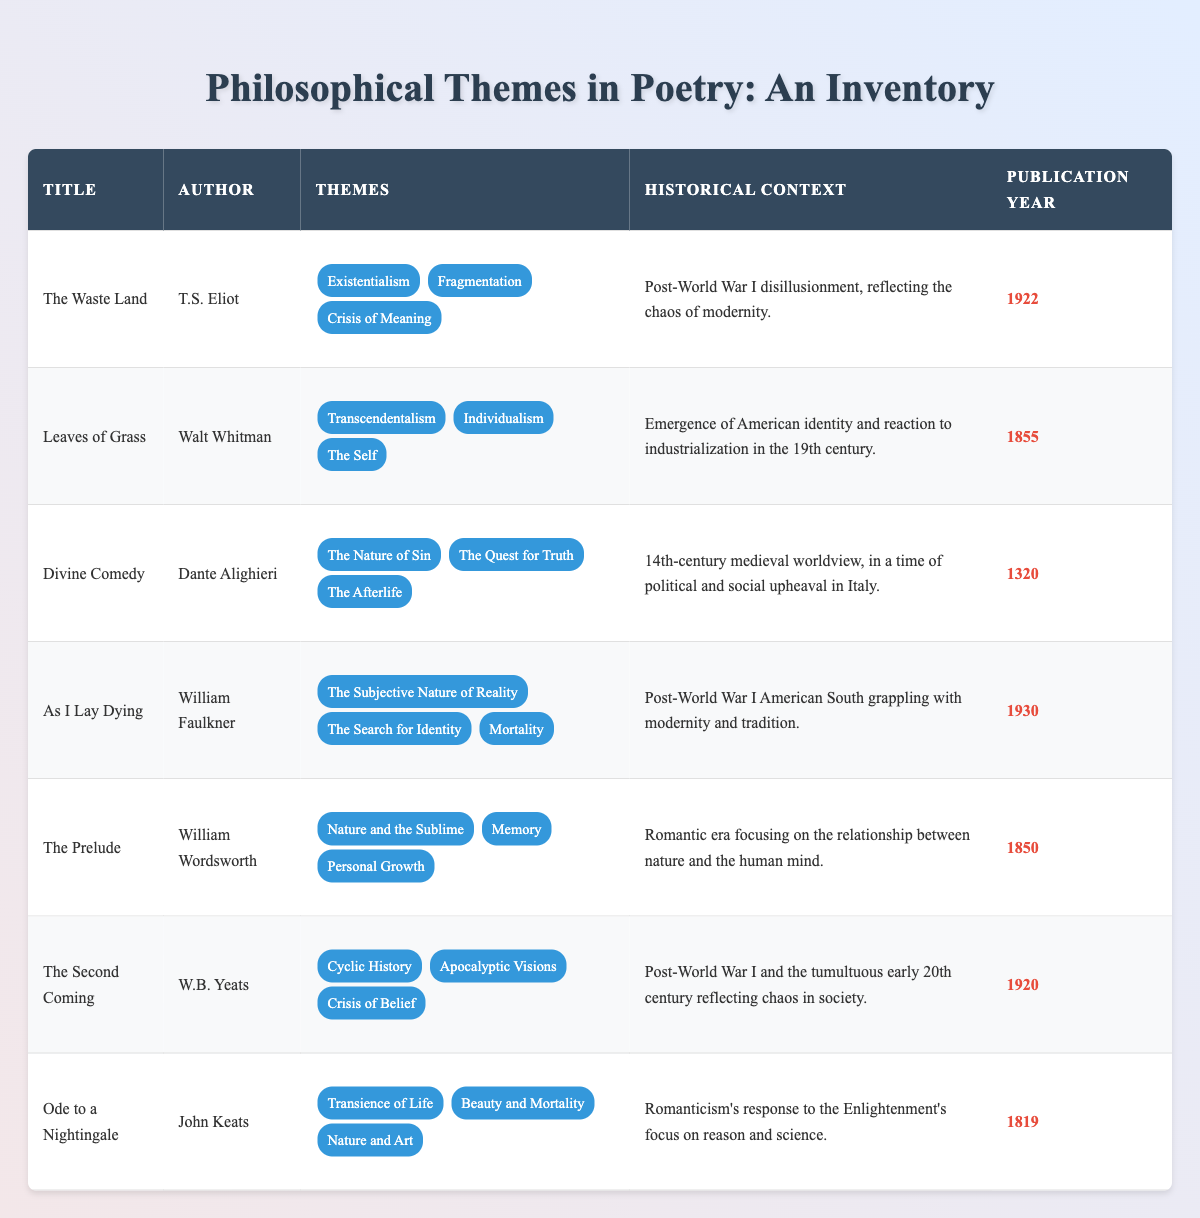What is the publication year of "The Waste Land"? The publication year for "The Waste Land" is listed in the table, where the corresponding row shows the year next to the title. Therefore, by checking the relevant column, we find that it was published in 1922.
Answer: 1922 Which author wrote "Leaves of Grass"? The title "Leaves of Grass" corresponds to the author listed in the same row of the table. Upon reviewing the author column for that title, we see it is Walt Whitman.
Answer: Walt Whitman How many themes are associated with "Ode to a Nightingale"? The number of themes for "Ode to a Nightingale" can be determined by counting the list of themes in the corresponding row of the table. There are three themes listed for this poem: Transience of Life, Beauty and Mortality, and Nature and Art.
Answer: 3 Which poem's themes include "Existentialism"? To answer this question, we look for the theme "Existentialism" in the themes column of the table. By scanning through the themes, we find that it is listed in the row for "The Waste Land."
Answer: The Waste Land Was "The Prelude" published before 1900? To determine this, we need to check the publication year for "The Prelude" in the table. The publication year is 1850, which is indeed before 1900.
Answer: Yes Which themes are present in both "The Second Coming" and "The Waste Land"? We review the themes for each of these two poems in their respective rows. "The Second Coming" includes Cyclic History, Apocalyptic Visions, and Crisis of Belief, while "The Waste Land" contains Existentialism, Fragmentation, and Crisis of Meaning. The only overlapping theme here is "Crisis of Meaning," which suggests a connection between the crises depicted in the two works.
Answer: Crisis of Meaning What is the historical context for "Divine Comedy"? The historical context can be found in the specific row corresponding to "Divine Comedy" in the table. It is noted as reflective of the 14th-century medieval worldview during a time of political and social upheaval in Italy. This detailed context helps us understand the environment in which Dante was writing.
Answer: 14th-century medieval worldview, in a time of political and social upheaval in Italy Which poem was published most recently in the table? To determine this, we need to compare the publication years of all poems listed. The most recent publication year present in the table is for "As I Lay Dying," published in 1930. Thus, by looking at the publication years, we can conclude which is the latest.
Answer: As I Lay Dying How many poems were published in the 19th century according to the table? To find the answer, we can scan the publication years of the poems and count those that fall within the 19th century (1801-1900). The poems "Leaves of Grass" (1855), "The Prelude" (1850), and "Ode to a Nightingale" (1819) were all published during that time. So, counting them gives us three poems in the 19th century.
Answer: 3 